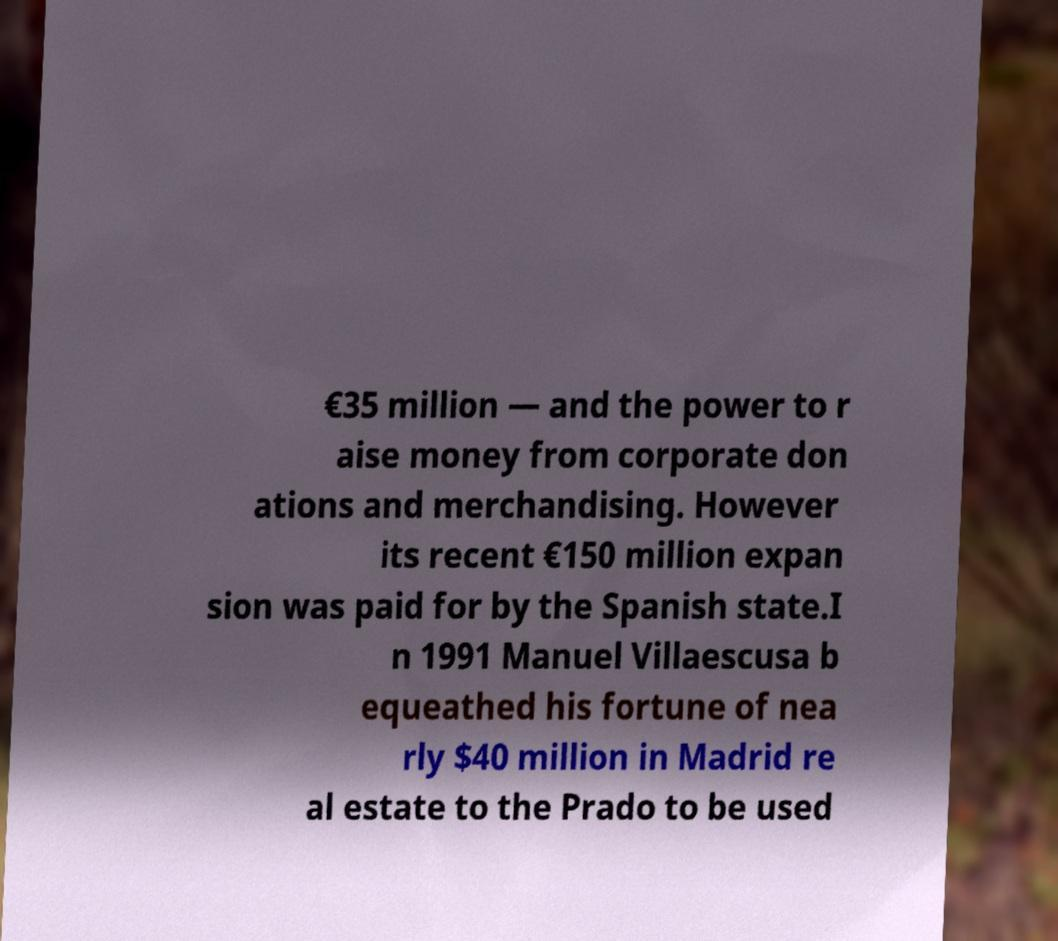Please read and relay the text visible in this image. What does it say? €35 million — and the power to r aise money from corporate don ations and merchandising. However its recent €150 million expan sion was paid for by the Spanish state.I n 1991 Manuel Villaescusa b equeathed his fortune of nea rly $40 million in Madrid re al estate to the Prado to be used 